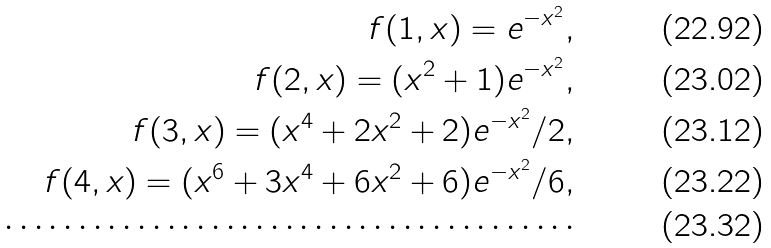<formula> <loc_0><loc_0><loc_500><loc_500>f ( 1 , x ) = e ^ { - x ^ { 2 } } , \\ f ( 2 , x ) = ( x ^ { 2 } + 1 ) e ^ { - x ^ { 2 } } , \\ f ( 3 , x ) = ( x ^ { 4 } + 2 x ^ { 2 } + 2 ) e ^ { - x ^ { 2 } } / 2 , \\ f ( 4 , x ) = ( x ^ { 6 } + 3 x ^ { 4 } + 6 x ^ { 2 } + 6 ) e ^ { - x ^ { 2 } } / 6 , \\ \cdots \cdots \cdots \cdots \cdots \cdots \cdots \cdots \cdots \cdots \cdots \cdots \cdots</formula> 